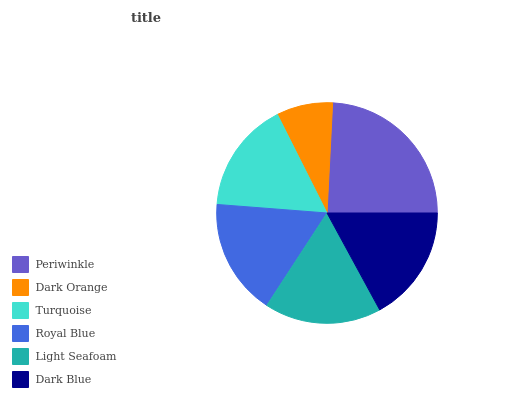Is Dark Orange the minimum?
Answer yes or no. Yes. Is Periwinkle the maximum?
Answer yes or no. Yes. Is Turquoise the minimum?
Answer yes or no. No. Is Turquoise the maximum?
Answer yes or no. No. Is Turquoise greater than Dark Orange?
Answer yes or no. Yes. Is Dark Orange less than Turquoise?
Answer yes or no. Yes. Is Dark Orange greater than Turquoise?
Answer yes or no. No. Is Turquoise less than Dark Orange?
Answer yes or no. No. Is Dark Blue the high median?
Answer yes or no. Yes. Is Royal Blue the low median?
Answer yes or no. Yes. Is Turquoise the high median?
Answer yes or no. No. Is Turquoise the low median?
Answer yes or no. No. 